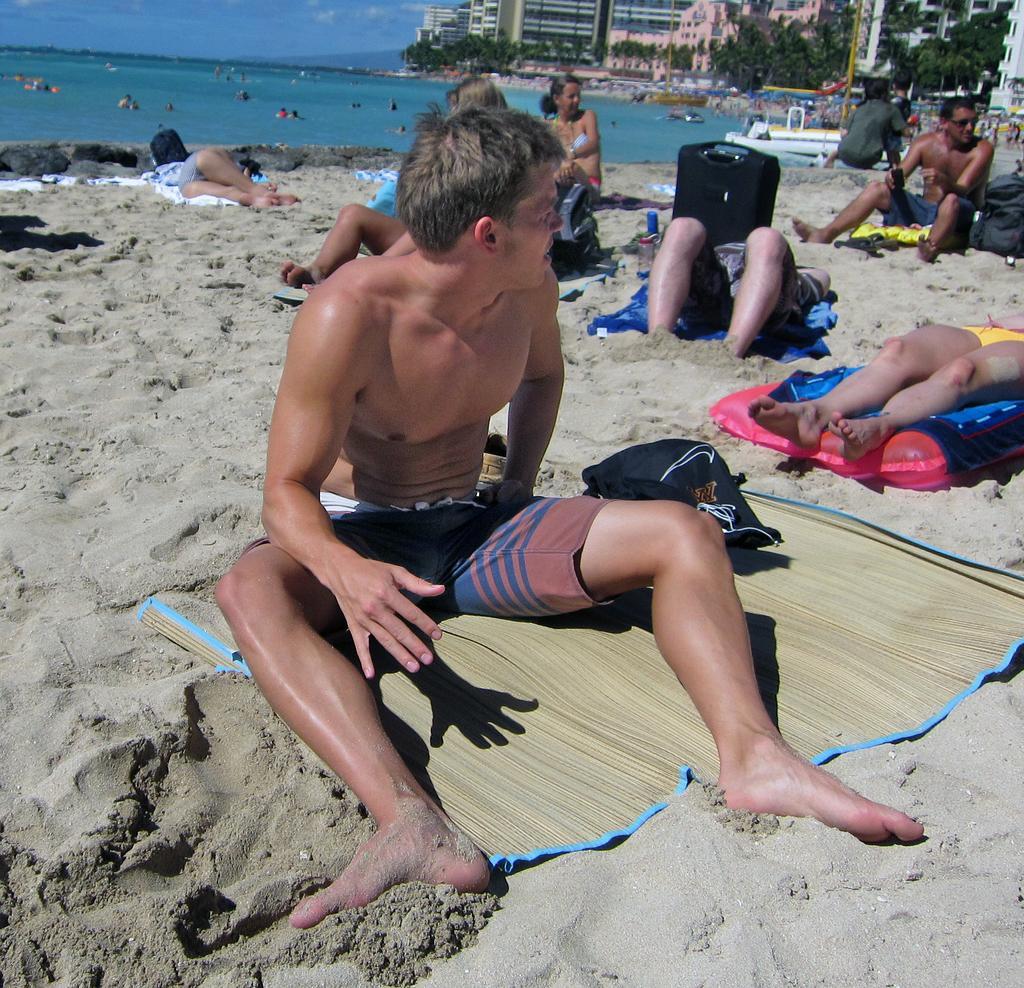How would you summarize this image in a sentence or two? In this image we can see sand. On the sand there are many people lying. Some are sitting. Also there is mat and clothes. In the background we can see people in the water. Also there are buildings and trees. And there is sky. 